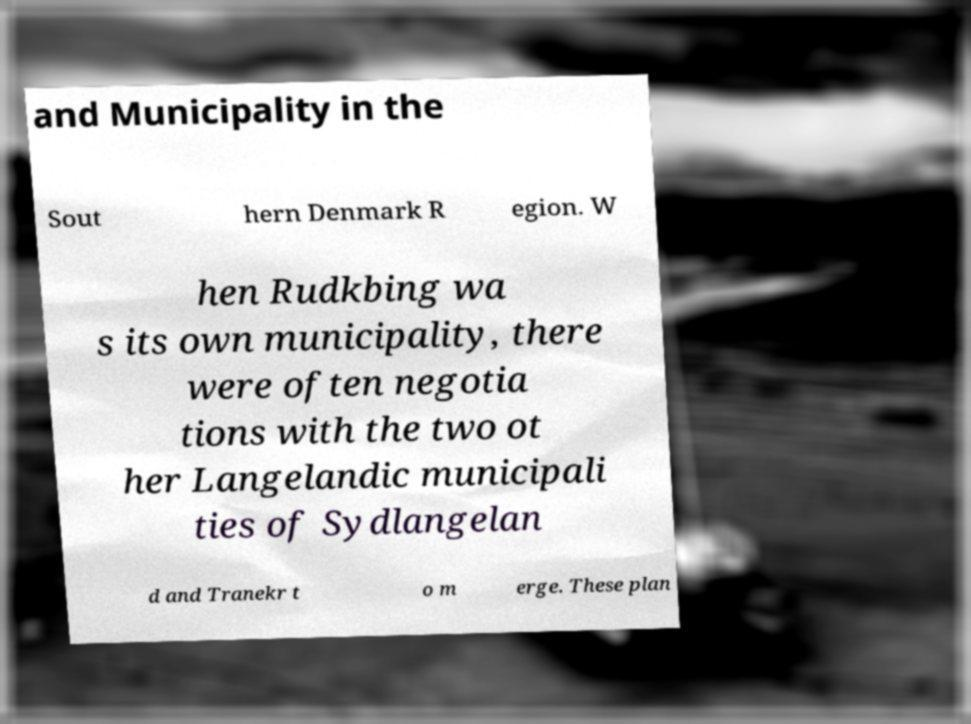Can you accurately transcribe the text from the provided image for me? and Municipality in the Sout hern Denmark R egion. W hen Rudkbing wa s its own municipality, there were often negotia tions with the two ot her Langelandic municipali ties of Sydlangelan d and Tranekr t o m erge. These plan 